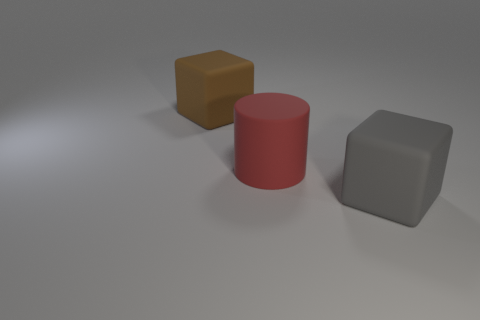Are there any red cylinders right of the big red thing?
Offer a terse response. No. Is the number of red matte cylinders that are to the right of the large cylinder less than the number of brown rubber objects?
Offer a terse response. Yes. What material is the large red object?
Offer a very short reply. Rubber. What color is the large matte cylinder?
Give a very brief answer. Red. What color is the matte thing that is both in front of the brown block and behind the big gray rubber object?
Offer a very short reply. Red. Is the material of the red object the same as the thing that is behind the big red object?
Make the answer very short. Yes. What is the size of the matte block that is to the right of the large rubber block behind the large gray block?
Provide a succinct answer. Large. Is there anything else that is the same color as the large matte cylinder?
Your answer should be very brief. No. Are the large gray thing that is right of the large red thing and the block that is behind the big gray rubber object made of the same material?
Provide a short and direct response. Yes. What is the large object that is both on the right side of the big brown matte cube and behind the gray thing made of?
Ensure brevity in your answer.  Rubber. 